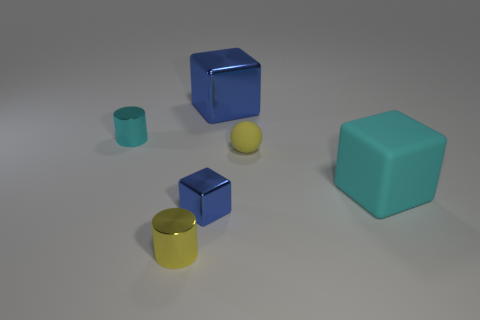Are there more cyan things than big green metal cubes?
Offer a very short reply. Yes. What number of other objects are there of the same color as the big metallic object?
Ensure brevity in your answer.  1. How many tiny yellow rubber things are in front of the metal block that is on the left side of the big blue shiny cube?
Your answer should be very brief. 0. There is a cyan matte block; are there any blue shiny things in front of it?
Keep it short and to the point. Yes. There is a blue metal thing that is behind the cyan thing that is left of the yellow cylinder; what is its shape?
Your answer should be compact. Cube. Are there fewer large cyan blocks in front of the tiny yellow ball than matte balls that are on the right side of the small blue metallic block?
Keep it short and to the point. No. There is another shiny object that is the same shape as the cyan shiny object; what color is it?
Your answer should be very brief. Yellow. How many objects are in front of the cyan shiny cylinder and to the right of the tiny blue metal block?
Offer a terse response. 2. Is the number of small cubes behind the big blue shiny block greater than the number of small yellow shiny objects that are right of the small yellow shiny object?
Your answer should be very brief. No. How big is the yellow shiny cylinder?
Offer a terse response. Small. 